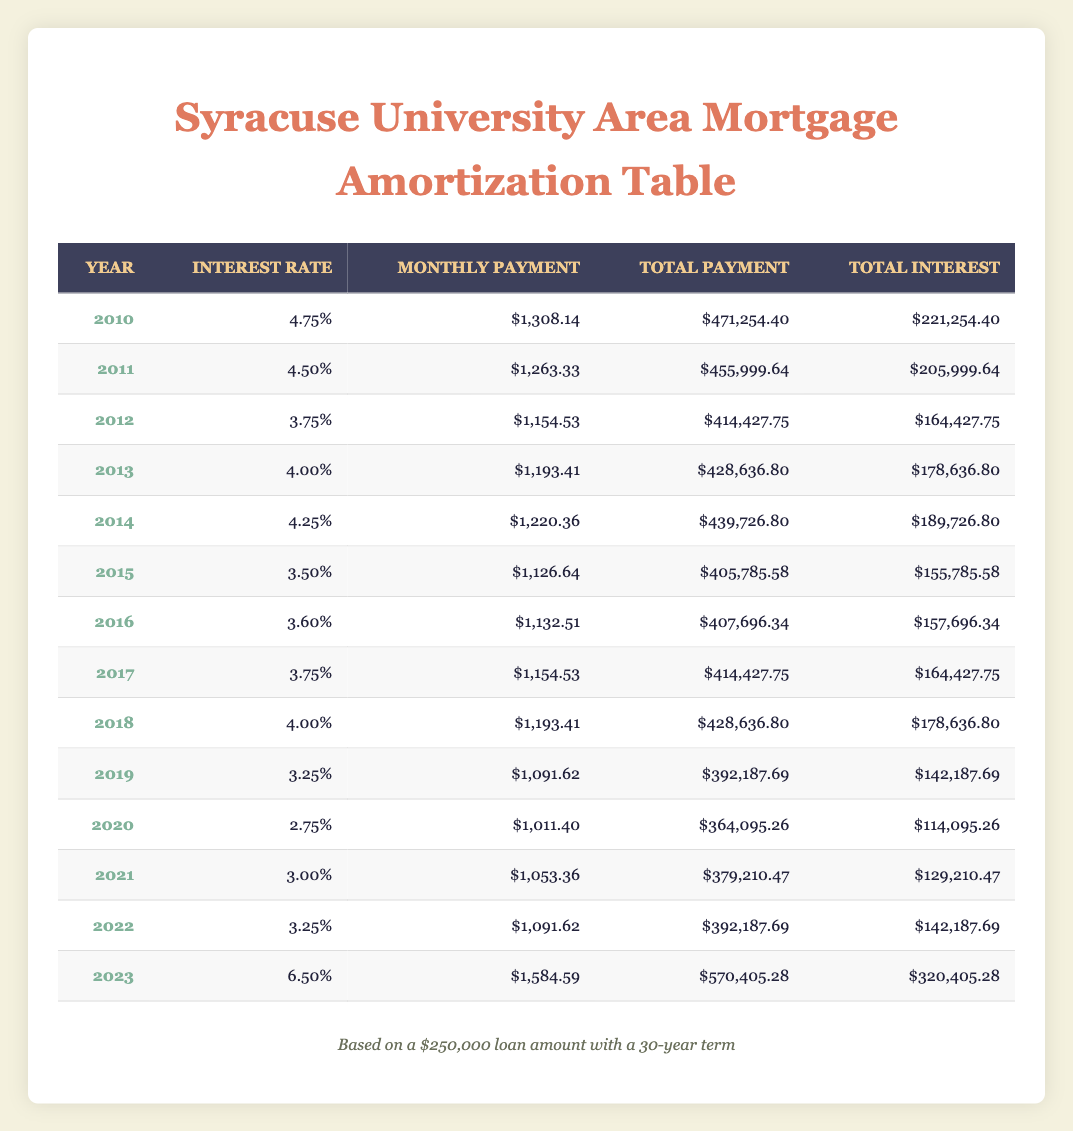What was the monthly payment for a mortgage in 2015? The table shows that for the year 2015, the monthly payment listed is $1,126.64.
Answer: $1,126.64 Which year had the highest interest rate according to the table? Looking at the interest rates for each year, 2023 has the highest rate listed at 6.50%.
Answer: 2023 What was the total interest paid in 2012? According to the table, for the year 2012, the total interest is $164,427.75.
Answer: $164,427.75 How much more did the total payment in 2023 differ from the total payment in 2010? The total payment in 2023 is $570,405.28 and in 2010 is $471,254.40. The difference is $570,405.28 - $471,254.40 = $99,150.88.
Answer: $99,150.88 Is the monthly payment in 2021 lower than in 2020? The monthly payment in 2021 is $1,053.36 and in 2020 is $1,011.40. Since $1,053.36 is not lower than $1,011.40, the answer is no.
Answer: No What is the average monthly payment from 2010 to 2019? First, we sum the monthly payments for these years: $1,308.14 + $1,263.33 + $1,154.53 + $1,193.41 + $1,220.36 + $1,126.64 + $1,132.51 + $1,154.53 + $1,091.62 = $11,439.12. There are 10 data points, so the average monthly payment is $11,439.12 / 10 = $1,143.91.
Answer: $1,143.91 What was the total payment for the year with the lowest interest rate? The lowest interest rate is 2.75%, which corresponds to the year 2020. The total payment for that year is $364,095.26.
Answer: $364,095.26 In what year was the monthly payment closest to $1,100? Checking the monthly payments, $1,091.62 in 2019 and $1,126.64 in 2015 are two closest values, but 2019 is the exact closest.
Answer: 2019 How much total interest was paid from 2010 to 2020? We sum the total interest amounts from 2010 to 2020: $221,254.40 + $205,999.64 + $164,427.75 + $178,636.80 + $189,726.80 + $155,785.58 + $157,696.34 + $142,187.69 + $114,095.26 = $1,930,768.16.
Answer: $1,930,768.16 